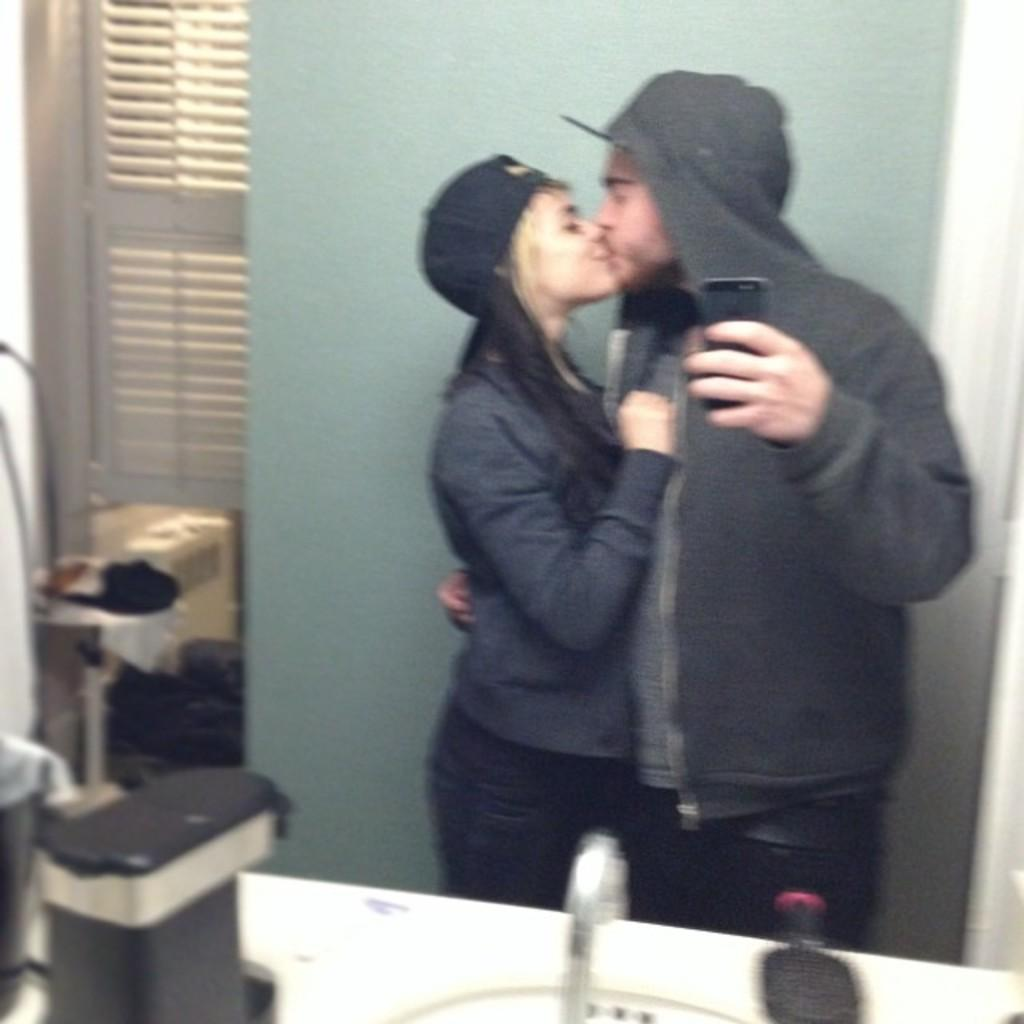What object can be seen in the image that is used for grooming hair? There is a comb in the image that is used for grooming hair. What object in the image is used for dispensing water? There is a tap in the image that is used for dispensing water. What type of structure is visible in the image? There is a wall in the image. What architectural feature is present in the image that allows natural light to enter? There is a window in the image. What object in the image is typically used for holding a phone? There is a mobile in the image that is typically used for holding a phone. What type of clothing accessory is present in the image? There is a cap in the image. How many people are visible in the image? There are two people standing in the image. What flavor of ice cream is being attacked by the comb in the image? There is no ice cream or attack present in the image. What type of surprise is hidden behind the wall in the image? There is no surprise hidden behind the wall in the image. 